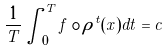Convert formula to latex. <formula><loc_0><loc_0><loc_500><loc_500>\frac { 1 } { T } \int _ { 0 } ^ { T } f \circ \rho ^ { t } ( x ) d t = c</formula> 